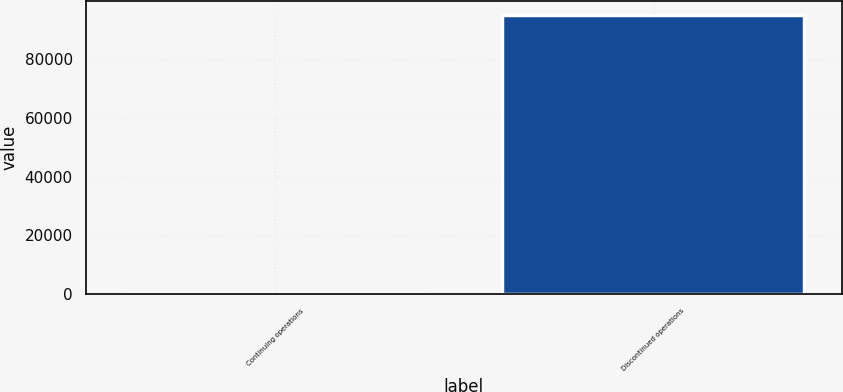Convert chart to OTSL. <chart><loc_0><loc_0><loc_500><loc_500><bar_chart><fcel>Continuing operations<fcel>Discontinued operations<nl><fcel>128<fcel>94776<nl></chart> 